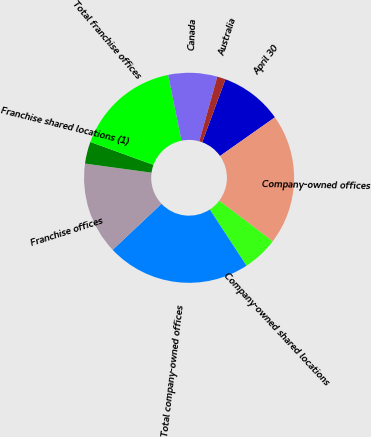Convert chart to OTSL. <chart><loc_0><loc_0><loc_500><loc_500><pie_chart><fcel>April 30<fcel>Company-owned offices<fcel>Company-owned shared locations<fcel>Total company-owned offices<fcel>Franchise offices<fcel>Franchise shared locations (1)<fcel>Total franchise offices<fcel>Canada<fcel>Australia<nl><fcel>9.6%<fcel>20.11%<fcel>5.45%<fcel>22.18%<fcel>14.19%<fcel>3.38%<fcel>16.26%<fcel>7.53%<fcel>1.3%<nl></chart> 